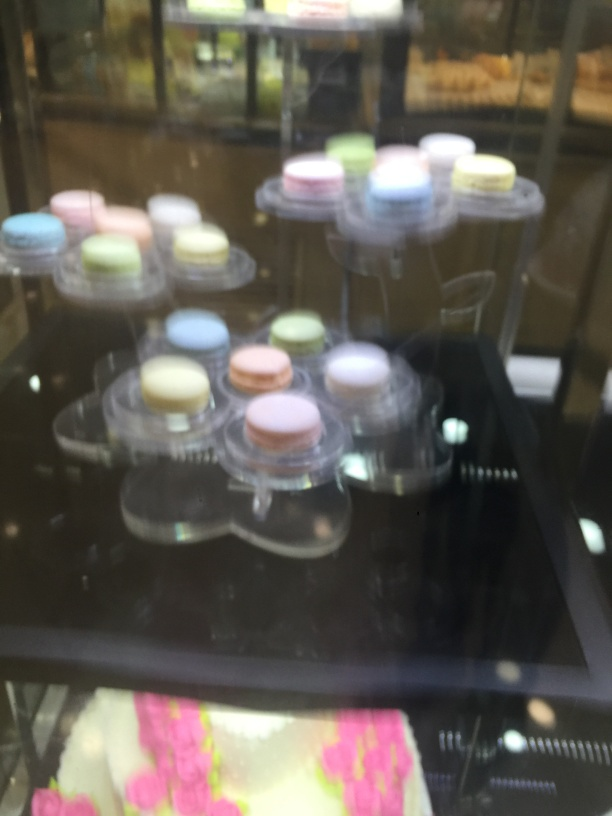What might have caused the motion blur in this photograph? The motion blur observed in the photo likely resulted from camera movement or a lower shutter speed setting used during the shot. It might have been unintentional, like an unsteady hand, or intentional to create a dynamic effect. However, in this case, it looks like it wasn't intended to be part of the composition. Could you tell me something about the objects in focus despite the blur? Despite the blur, the objects in focus appear to be colorful circular items arranged on tiers. Based on their pastel colors and the setting, they might be macarons, a popular French confection made from almond flour, sugar, and egg whites, often with a creamy filling. 